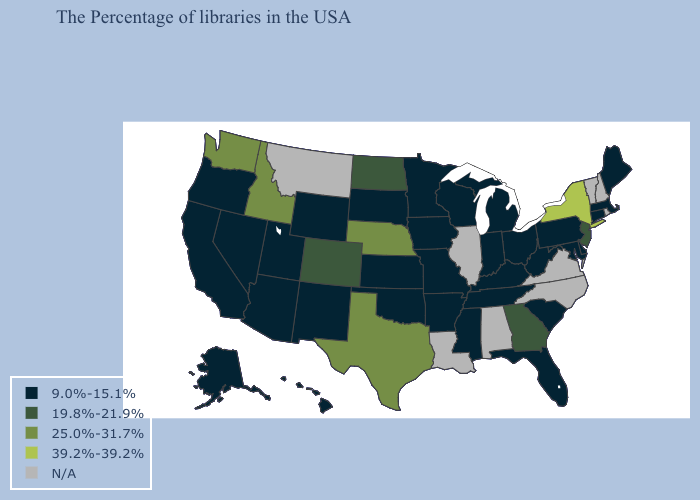How many symbols are there in the legend?
Answer briefly. 5. Does the first symbol in the legend represent the smallest category?
Quick response, please. Yes. Does Texas have the highest value in the South?
Concise answer only. Yes. What is the value of Alaska?
Quick response, please. 9.0%-15.1%. Name the states that have a value in the range N/A?
Be succinct. Rhode Island, New Hampshire, Vermont, Virginia, North Carolina, Alabama, Illinois, Louisiana, Montana. Among the states that border Colorado , which have the highest value?
Write a very short answer. Nebraska. Name the states that have a value in the range 19.8%-21.9%?
Quick response, please. New Jersey, Georgia, North Dakota, Colorado. Is the legend a continuous bar?
Keep it brief. No. Which states have the lowest value in the MidWest?
Give a very brief answer. Ohio, Michigan, Indiana, Wisconsin, Missouri, Minnesota, Iowa, Kansas, South Dakota. Name the states that have a value in the range 25.0%-31.7%?
Be succinct. Nebraska, Texas, Idaho, Washington. What is the value of Illinois?
Write a very short answer. N/A. What is the lowest value in the Northeast?
Be succinct. 9.0%-15.1%. Name the states that have a value in the range 25.0%-31.7%?
Short answer required. Nebraska, Texas, Idaho, Washington. Name the states that have a value in the range 19.8%-21.9%?
Be succinct. New Jersey, Georgia, North Dakota, Colorado. 